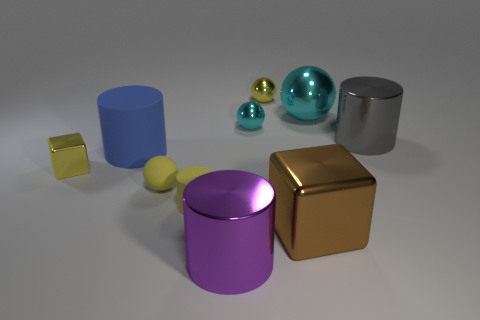What number of cylinders are either brown objects or large rubber objects?
Make the answer very short. 1. What number of cyan objects are the same size as the yellow metal ball?
Offer a terse response. 1. There is a tiny rubber object that is in front of the matte ball; how many metal blocks are right of it?
Provide a succinct answer. 1. There is a shiny thing that is both in front of the large blue cylinder and behind the large brown object; what is its size?
Make the answer very short. Small. Are there more large spheres than cyan shiny spheres?
Offer a very short reply. No. Are there any large metallic cylinders of the same color as the small matte ball?
Offer a very short reply. No. Does the brown thing in front of the yellow block have the same size as the yellow cylinder?
Your answer should be very brief. No. Is the number of matte cylinders less than the number of purple spheres?
Provide a succinct answer. No. Is there a tiny thing that has the same material as the tiny cube?
Ensure brevity in your answer.  Yes. The cyan metal thing that is left of the large cyan shiny thing has what shape?
Make the answer very short. Sphere. 